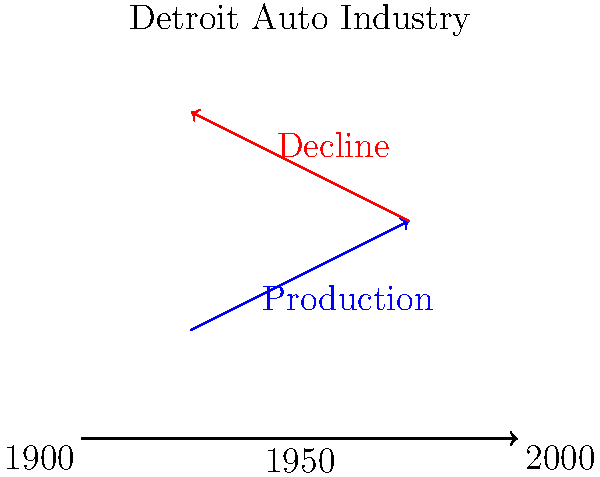Based on the vector diagram representing Detroit's automotive production history, which direction does the blue vector point, and what does this indicate about the industry's trajectory from 1900 to 1950? To answer this question, let's analyze the vector diagram step-by-step:

1. The horizontal axis represents a timeline from 1900 to 2000, with 1950 at the midpoint.

2. There are two vectors in the diagram:
   a) A blue vector starting around 1900 and pointing upward and to the right.
   b) A red vector starting around 1950 and pointing downward and to the left.

3. The blue vector is labeled "Production" and spans the period from approximately 1900 to 1950.

4. The direction of the blue vector is important:
   - It points upward, indicating an increase or growth.
   - It points to the right, following the timeline's progression.

5. In the context of Detroit's automotive industry:
   - An upward-pointing vector suggests an increase in production or economic growth.
   - The rightward direction aligns with the passage of time from 1900 to 1950.

6. This upward and rightward trajectory of the blue vector indicates that from 1900 to 1950, Detroit's automotive industry experienced significant growth and increased production.

7. The period from 1900 to 1950 aligns with historical facts about Detroit's rise as the center of the American automotive industry, including the establishment and rapid growth of major car manufacturers like Ford, General Motors, and Chrysler.
Answer: Upward and rightward, indicating growth in Detroit's automotive production from 1900 to 1950. 